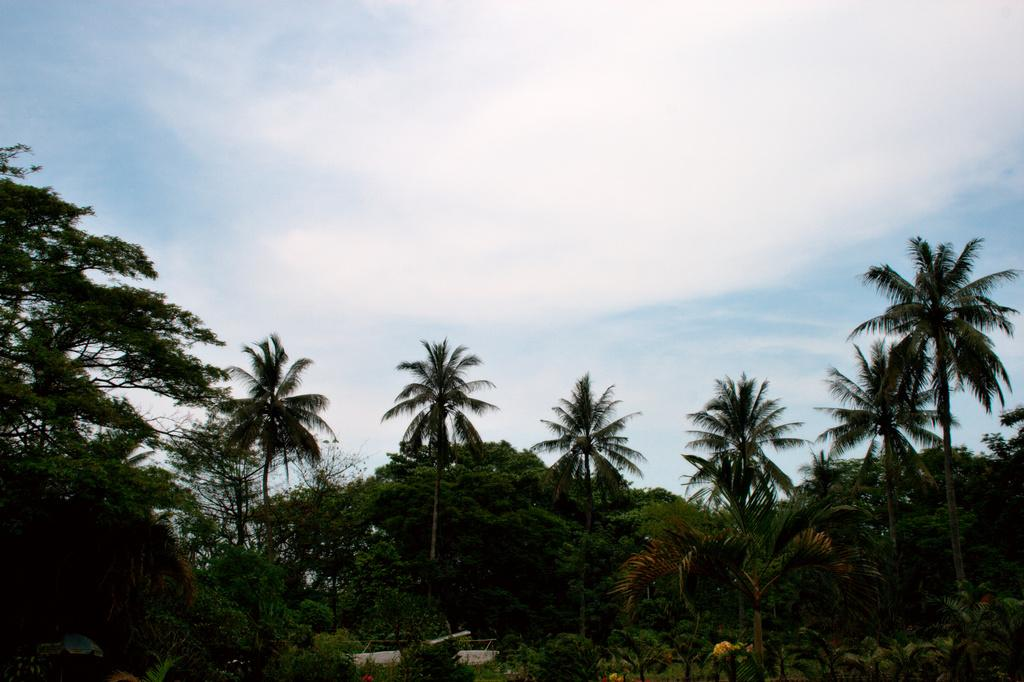What type of vegetation can be seen in the image? There are trees in the image. Can you identify any specific type of tree in the image? Some of the trees are coconut trees. What belief system is depicted on the page in the image? There is no page present in the image, and therefore no belief system can be observed. 